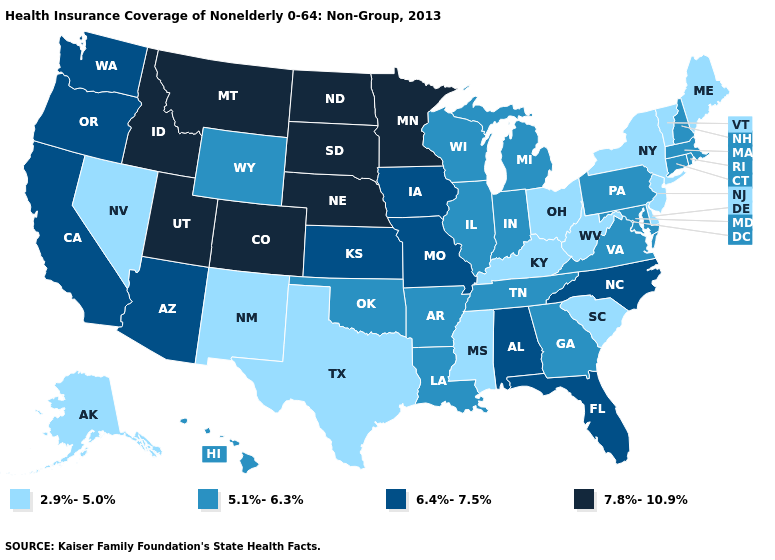Name the states that have a value in the range 5.1%-6.3%?
Concise answer only. Arkansas, Connecticut, Georgia, Hawaii, Illinois, Indiana, Louisiana, Maryland, Massachusetts, Michigan, New Hampshire, Oklahoma, Pennsylvania, Rhode Island, Tennessee, Virginia, Wisconsin, Wyoming. What is the lowest value in states that border Rhode Island?
Give a very brief answer. 5.1%-6.3%. Is the legend a continuous bar?
Keep it brief. No. Name the states that have a value in the range 6.4%-7.5%?
Answer briefly. Alabama, Arizona, California, Florida, Iowa, Kansas, Missouri, North Carolina, Oregon, Washington. Which states have the highest value in the USA?
Be succinct. Colorado, Idaho, Minnesota, Montana, Nebraska, North Dakota, South Dakota, Utah. Which states hav the highest value in the Northeast?
Give a very brief answer. Connecticut, Massachusetts, New Hampshire, Pennsylvania, Rhode Island. Does Mississippi have the lowest value in the USA?
Concise answer only. Yes. Among the states that border South Carolina , which have the lowest value?
Write a very short answer. Georgia. What is the value of Ohio?
Concise answer only. 2.9%-5.0%. Which states hav the highest value in the South?
Short answer required. Alabama, Florida, North Carolina. Does the first symbol in the legend represent the smallest category?
Be succinct. Yes. What is the value of Connecticut?
Write a very short answer. 5.1%-6.3%. Does Colorado have the same value as Tennessee?
Give a very brief answer. No. Among the states that border Kansas , does Colorado have the lowest value?
Give a very brief answer. No. 